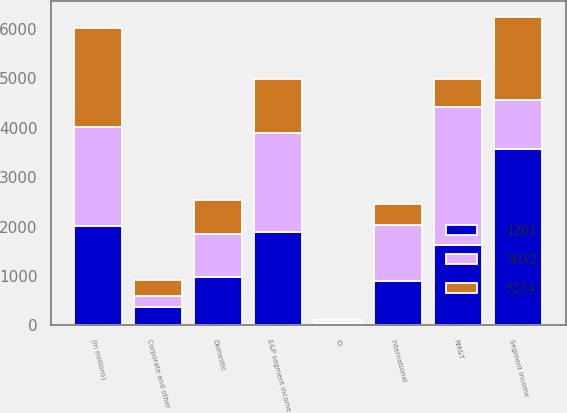Convert chart. <chart><loc_0><loc_0><loc_500><loc_500><stacked_bar_chart><ecel><fcel>(In millions)<fcel>Domestic<fcel>International<fcel>E&P segment income<fcel>RM&T<fcel>IG<fcel>Segment income<fcel>Corporate and other<nl><fcel>3032<fcel>2006<fcel>873<fcel>1130<fcel>2003<fcel>2795<fcel>16<fcel>983<fcel>212<nl><fcel>1261<fcel>2005<fcel>983<fcel>904<fcel>1887<fcel>1628<fcel>55<fcel>3570<fcel>377<nl><fcel>5234<fcel>2004<fcel>674<fcel>416<fcel>1090<fcel>568<fcel>37<fcel>1695<fcel>327<nl></chart> 